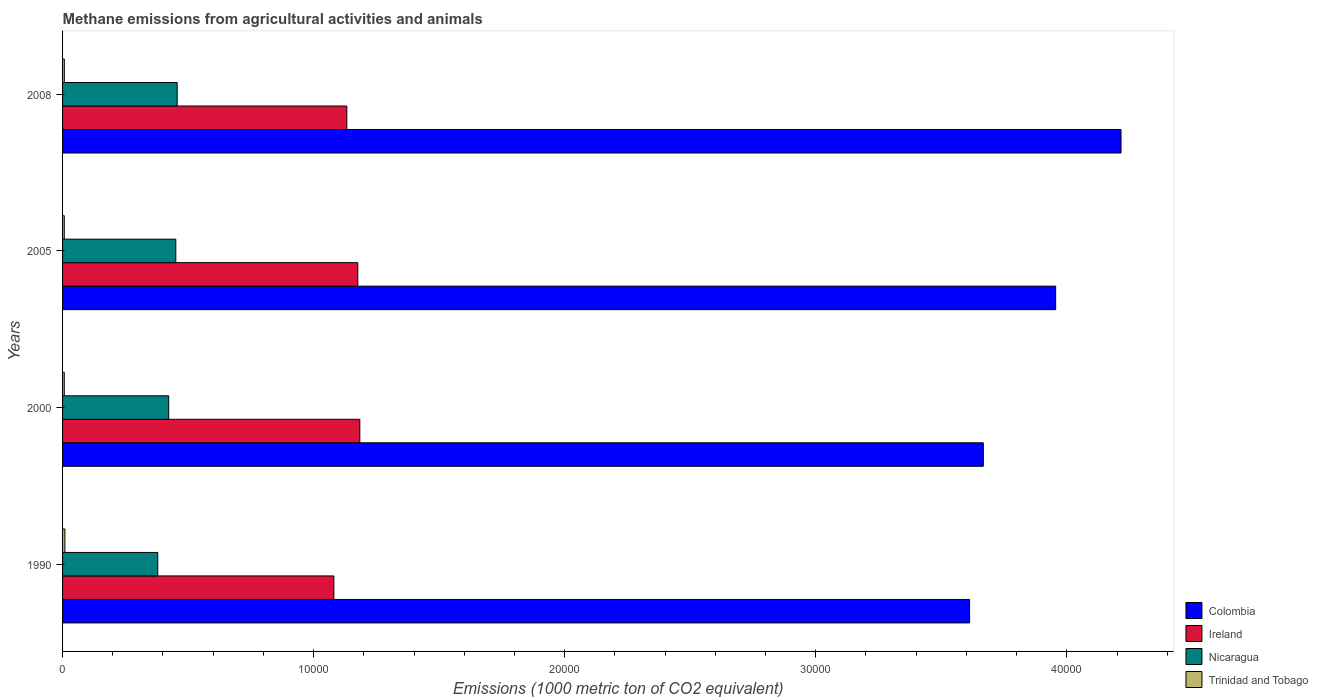How many different coloured bars are there?
Ensure brevity in your answer.  4. How many groups of bars are there?
Give a very brief answer. 4. What is the label of the 1st group of bars from the top?
Provide a short and direct response. 2008. What is the amount of methane emitted in Ireland in 1990?
Offer a terse response. 1.08e+04. Across all years, what is the maximum amount of methane emitted in Ireland?
Provide a short and direct response. 1.18e+04. Across all years, what is the minimum amount of methane emitted in Ireland?
Provide a succinct answer. 1.08e+04. What is the total amount of methane emitted in Trinidad and Tobago in the graph?
Give a very brief answer. 299.8. What is the difference between the amount of methane emitted in Trinidad and Tobago in 2005 and that in 2008?
Give a very brief answer. -2.9. What is the difference between the amount of methane emitted in Trinidad and Tobago in 2005 and the amount of methane emitted in Ireland in 2008?
Your response must be concise. -1.13e+04. What is the average amount of methane emitted in Nicaragua per year?
Your response must be concise. 4273.6. In the year 2000, what is the difference between the amount of methane emitted in Trinidad and Tobago and amount of methane emitted in Colombia?
Offer a very short reply. -3.66e+04. What is the ratio of the amount of methane emitted in Colombia in 2000 to that in 2008?
Offer a terse response. 0.87. Is the difference between the amount of methane emitted in Trinidad and Tobago in 1990 and 2000 greater than the difference between the amount of methane emitted in Colombia in 1990 and 2000?
Provide a succinct answer. Yes. What is the difference between the highest and the second highest amount of methane emitted in Ireland?
Provide a succinct answer. 81.2. What is the difference between the highest and the lowest amount of methane emitted in Trinidad and Tobago?
Ensure brevity in your answer.  24.7. In how many years, is the amount of methane emitted in Ireland greater than the average amount of methane emitted in Ireland taken over all years?
Make the answer very short. 2. Is it the case that in every year, the sum of the amount of methane emitted in Colombia and amount of methane emitted in Nicaragua is greater than the sum of amount of methane emitted in Ireland and amount of methane emitted in Trinidad and Tobago?
Offer a terse response. No. What does the 1st bar from the top in 2008 represents?
Make the answer very short. Trinidad and Tobago. What does the 2nd bar from the bottom in 2000 represents?
Your answer should be compact. Ireland. How many bars are there?
Keep it short and to the point. 16. Are all the bars in the graph horizontal?
Make the answer very short. Yes. How many years are there in the graph?
Your answer should be very brief. 4. Does the graph contain any zero values?
Your response must be concise. No. Does the graph contain grids?
Provide a succinct answer. No. Where does the legend appear in the graph?
Ensure brevity in your answer.  Bottom right. How are the legend labels stacked?
Make the answer very short. Vertical. What is the title of the graph?
Offer a terse response. Methane emissions from agricultural activities and animals. What is the label or title of the X-axis?
Ensure brevity in your answer.  Emissions (1000 metric ton of CO2 equivalent). What is the Emissions (1000 metric ton of CO2 equivalent) in Colombia in 1990?
Provide a succinct answer. 3.61e+04. What is the Emissions (1000 metric ton of CO2 equivalent) of Ireland in 1990?
Provide a short and direct response. 1.08e+04. What is the Emissions (1000 metric ton of CO2 equivalent) of Nicaragua in 1990?
Your response must be concise. 3791.8. What is the Emissions (1000 metric ton of CO2 equivalent) of Trinidad and Tobago in 1990?
Ensure brevity in your answer.  92.7. What is the Emissions (1000 metric ton of CO2 equivalent) of Colombia in 2000?
Offer a terse response. 3.67e+04. What is the Emissions (1000 metric ton of CO2 equivalent) in Ireland in 2000?
Give a very brief answer. 1.18e+04. What is the Emissions (1000 metric ton of CO2 equivalent) in Nicaragua in 2000?
Give a very brief answer. 4227.1. What is the Emissions (1000 metric ton of CO2 equivalent) in Colombia in 2005?
Make the answer very short. 3.96e+04. What is the Emissions (1000 metric ton of CO2 equivalent) in Ireland in 2005?
Offer a very short reply. 1.18e+04. What is the Emissions (1000 metric ton of CO2 equivalent) of Nicaragua in 2005?
Provide a succinct answer. 4510. What is the Emissions (1000 metric ton of CO2 equivalent) of Trinidad and Tobago in 2005?
Provide a succinct answer. 68.1. What is the Emissions (1000 metric ton of CO2 equivalent) in Colombia in 2008?
Offer a very short reply. 4.22e+04. What is the Emissions (1000 metric ton of CO2 equivalent) in Ireland in 2008?
Ensure brevity in your answer.  1.13e+04. What is the Emissions (1000 metric ton of CO2 equivalent) in Nicaragua in 2008?
Your answer should be very brief. 4565.5. What is the Emissions (1000 metric ton of CO2 equivalent) in Trinidad and Tobago in 2008?
Make the answer very short. 71. Across all years, what is the maximum Emissions (1000 metric ton of CO2 equivalent) in Colombia?
Give a very brief answer. 4.22e+04. Across all years, what is the maximum Emissions (1000 metric ton of CO2 equivalent) of Ireland?
Ensure brevity in your answer.  1.18e+04. Across all years, what is the maximum Emissions (1000 metric ton of CO2 equivalent) in Nicaragua?
Your response must be concise. 4565.5. Across all years, what is the maximum Emissions (1000 metric ton of CO2 equivalent) of Trinidad and Tobago?
Offer a terse response. 92.7. Across all years, what is the minimum Emissions (1000 metric ton of CO2 equivalent) of Colombia?
Offer a very short reply. 3.61e+04. Across all years, what is the minimum Emissions (1000 metric ton of CO2 equivalent) of Ireland?
Ensure brevity in your answer.  1.08e+04. Across all years, what is the minimum Emissions (1000 metric ton of CO2 equivalent) in Nicaragua?
Your response must be concise. 3791.8. What is the total Emissions (1000 metric ton of CO2 equivalent) of Colombia in the graph?
Your answer should be very brief. 1.55e+05. What is the total Emissions (1000 metric ton of CO2 equivalent) of Ireland in the graph?
Keep it short and to the point. 4.57e+04. What is the total Emissions (1000 metric ton of CO2 equivalent) of Nicaragua in the graph?
Provide a short and direct response. 1.71e+04. What is the total Emissions (1000 metric ton of CO2 equivalent) in Trinidad and Tobago in the graph?
Your answer should be very brief. 299.8. What is the difference between the Emissions (1000 metric ton of CO2 equivalent) of Colombia in 1990 and that in 2000?
Your response must be concise. -546.7. What is the difference between the Emissions (1000 metric ton of CO2 equivalent) in Ireland in 1990 and that in 2000?
Provide a succinct answer. -1033.1. What is the difference between the Emissions (1000 metric ton of CO2 equivalent) of Nicaragua in 1990 and that in 2000?
Ensure brevity in your answer.  -435.3. What is the difference between the Emissions (1000 metric ton of CO2 equivalent) in Trinidad and Tobago in 1990 and that in 2000?
Offer a very short reply. 24.7. What is the difference between the Emissions (1000 metric ton of CO2 equivalent) of Colombia in 1990 and that in 2005?
Your response must be concise. -3428.3. What is the difference between the Emissions (1000 metric ton of CO2 equivalent) in Ireland in 1990 and that in 2005?
Offer a terse response. -951.9. What is the difference between the Emissions (1000 metric ton of CO2 equivalent) in Nicaragua in 1990 and that in 2005?
Offer a very short reply. -718.2. What is the difference between the Emissions (1000 metric ton of CO2 equivalent) in Trinidad and Tobago in 1990 and that in 2005?
Provide a succinct answer. 24.6. What is the difference between the Emissions (1000 metric ton of CO2 equivalent) of Colombia in 1990 and that in 2008?
Your answer should be compact. -6031.9. What is the difference between the Emissions (1000 metric ton of CO2 equivalent) of Ireland in 1990 and that in 2008?
Keep it short and to the point. -516. What is the difference between the Emissions (1000 metric ton of CO2 equivalent) of Nicaragua in 1990 and that in 2008?
Ensure brevity in your answer.  -773.7. What is the difference between the Emissions (1000 metric ton of CO2 equivalent) in Trinidad and Tobago in 1990 and that in 2008?
Your answer should be compact. 21.7. What is the difference between the Emissions (1000 metric ton of CO2 equivalent) of Colombia in 2000 and that in 2005?
Make the answer very short. -2881.6. What is the difference between the Emissions (1000 metric ton of CO2 equivalent) of Ireland in 2000 and that in 2005?
Keep it short and to the point. 81.2. What is the difference between the Emissions (1000 metric ton of CO2 equivalent) of Nicaragua in 2000 and that in 2005?
Offer a terse response. -282.9. What is the difference between the Emissions (1000 metric ton of CO2 equivalent) of Trinidad and Tobago in 2000 and that in 2005?
Offer a very short reply. -0.1. What is the difference between the Emissions (1000 metric ton of CO2 equivalent) of Colombia in 2000 and that in 2008?
Give a very brief answer. -5485.2. What is the difference between the Emissions (1000 metric ton of CO2 equivalent) of Ireland in 2000 and that in 2008?
Your answer should be very brief. 517.1. What is the difference between the Emissions (1000 metric ton of CO2 equivalent) of Nicaragua in 2000 and that in 2008?
Provide a short and direct response. -338.4. What is the difference between the Emissions (1000 metric ton of CO2 equivalent) in Colombia in 2005 and that in 2008?
Your answer should be compact. -2603.6. What is the difference between the Emissions (1000 metric ton of CO2 equivalent) of Ireland in 2005 and that in 2008?
Offer a very short reply. 435.9. What is the difference between the Emissions (1000 metric ton of CO2 equivalent) of Nicaragua in 2005 and that in 2008?
Your answer should be very brief. -55.5. What is the difference between the Emissions (1000 metric ton of CO2 equivalent) in Colombia in 1990 and the Emissions (1000 metric ton of CO2 equivalent) in Ireland in 2000?
Offer a terse response. 2.43e+04. What is the difference between the Emissions (1000 metric ton of CO2 equivalent) of Colombia in 1990 and the Emissions (1000 metric ton of CO2 equivalent) of Nicaragua in 2000?
Provide a short and direct response. 3.19e+04. What is the difference between the Emissions (1000 metric ton of CO2 equivalent) of Colombia in 1990 and the Emissions (1000 metric ton of CO2 equivalent) of Trinidad and Tobago in 2000?
Ensure brevity in your answer.  3.61e+04. What is the difference between the Emissions (1000 metric ton of CO2 equivalent) in Ireland in 1990 and the Emissions (1000 metric ton of CO2 equivalent) in Nicaragua in 2000?
Keep it short and to the point. 6579.4. What is the difference between the Emissions (1000 metric ton of CO2 equivalent) of Ireland in 1990 and the Emissions (1000 metric ton of CO2 equivalent) of Trinidad and Tobago in 2000?
Ensure brevity in your answer.  1.07e+04. What is the difference between the Emissions (1000 metric ton of CO2 equivalent) of Nicaragua in 1990 and the Emissions (1000 metric ton of CO2 equivalent) of Trinidad and Tobago in 2000?
Offer a very short reply. 3723.8. What is the difference between the Emissions (1000 metric ton of CO2 equivalent) in Colombia in 1990 and the Emissions (1000 metric ton of CO2 equivalent) in Ireland in 2005?
Provide a short and direct response. 2.44e+04. What is the difference between the Emissions (1000 metric ton of CO2 equivalent) in Colombia in 1990 and the Emissions (1000 metric ton of CO2 equivalent) in Nicaragua in 2005?
Provide a short and direct response. 3.16e+04. What is the difference between the Emissions (1000 metric ton of CO2 equivalent) of Colombia in 1990 and the Emissions (1000 metric ton of CO2 equivalent) of Trinidad and Tobago in 2005?
Your answer should be compact. 3.61e+04. What is the difference between the Emissions (1000 metric ton of CO2 equivalent) of Ireland in 1990 and the Emissions (1000 metric ton of CO2 equivalent) of Nicaragua in 2005?
Keep it short and to the point. 6296.5. What is the difference between the Emissions (1000 metric ton of CO2 equivalent) of Ireland in 1990 and the Emissions (1000 metric ton of CO2 equivalent) of Trinidad and Tobago in 2005?
Provide a succinct answer. 1.07e+04. What is the difference between the Emissions (1000 metric ton of CO2 equivalent) in Nicaragua in 1990 and the Emissions (1000 metric ton of CO2 equivalent) in Trinidad and Tobago in 2005?
Provide a succinct answer. 3723.7. What is the difference between the Emissions (1000 metric ton of CO2 equivalent) in Colombia in 1990 and the Emissions (1000 metric ton of CO2 equivalent) in Ireland in 2008?
Offer a very short reply. 2.48e+04. What is the difference between the Emissions (1000 metric ton of CO2 equivalent) in Colombia in 1990 and the Emissions (1000 metric ton of CO2 equivalent) in Nicaragua in 2008?
Your response must be concise. 3.16e+04. What is the difference between the Emissions (1000 metric ton of CO2 equivalent) in Colombia in 1990 and the Emissions (1000 metric ton of CO2 equivalent) in Trinidad and Tobago in 2008?
Keep it short and to the point. 3.61e+04. What is the difference between the Emissions (1000 metric ton of CO2 equivalent) of Ireland in 1990 and the Emissions (1000 metric ton of CO2 equivalent) of Nicaragua in 2008?
Ensure brevity in your answer.  6241. What is the difference between the Emissions (1000 metric ton of CO2 equivalent) in Ireland in 1990 and the Emissions (1000 metric ton of CO2 equivalent) in Trinidad and Tobago in 2008?
Make the answer very short. 1.07e+04. What is the difference between the Emissions (1000 metric ton of CO2 equivalent) in Nicaragua in 1990 and the Emissions (1000 metric ton of CO2 equivalent) in Trinidad and Tobago in 2008?
Your response must be concise. 3720.8. What is the difference between the Emissions (1000 metric ton of CO2 equivalent) in Colombia in 2000 and the Emissions (1000 metric ton of CO2 equivalent) in Ireland in 2005?
Ensure brevity in your answer.  2.49e+04. What is the difference between the Emissions (1000 metric ton of CO2 equivalent) in Colombia in 2000 and the Emissions (1000 metric ton of CO2 equivalent) in Nicaragua in 2005?
Give a very brief answer. 3.22e+04. What is the difference between the Emissions (1000 metric ton of CO2 equivalent) in Colombia in 2000 and the Emissions (1000 metric ton of CO2 equivalent) in Trinidad and Tobago in 2005?
Ensure brevity in your answer.  3.66e+04. What is the difference between the Emissions (1000 metric ton of CO2 equivalent) in Ireland in 2000 and the Emissions (1000 metric ton of CO2 equivalent) in Nicaragua in 2005?
Offer a terse response. 7329.6. What is the difference between the Emissions (1000 metric ton of CO2 equivalent) of Ireland in 2000 and the Emissions (1000 metric ton of CO2 equivalent) of Trinidad and Tobago in 2005?
Your answer should be compact. 1.18e+04. What is the difference between the Emissions (1000 metric ton of CO2 equivalent) in Nicaragua in 2000 and the Emissions (1000 metric ton of CO2 equivalent) in Trinidad and Tobago in 2005?
Offer a very short reply. 4159. What is the difference between the Emissions (1000 metric ton of CO2 equivalent) of Colombia in 2000 and the Emissions (1000 metric ton of CO2 equivalent) of Ireland in 2008?
Offer a very short reply. 2.54e+04. What is the difference between the Emissions (1000 metric ton of CO2 equivalent) of Colombia in 2000 and the Emissions (1000 metric ton of CO2 equivalent) of Nicaragua in 2008?
Ensure brevity in your answer.  3.21e+04. What is the difference between the Emissions (1000 metric ton of CO2 equivalent) of Colombia in 2000 and the Emissions (1000 metric ton of CO2 equivalent) of Trinidad and Tobago in 2008?
Ensure brevity in your answer.  3.66e+04. What is the difference between the Emissions (1000 metric ton of CO2 equivalent) of Ireland in 2000 and the Emissions (1000 metric ton of CO2 equivalent) of Nicaragua in 2008?
Provide a short and direct response. 7274.1. What is the difference between the Emissions (1000 metric ton of CO2 equivalent) in Ireland in 2000 and the Emissions (1000 metric ton of CO2 equivalent) in Trinidad and Tobago in 2008?
Ensure brevity in your answer.  1.18e+04. What is the difference between the Emissions (1000 metric ton of CO2 equivalent) of Nicaragua in 2000 and the Emissions (1000 metric ton of CO2 equivalent) of Trinidad and Tobago in 2008?
Give a very brief answer. 4156.1. What is the difference between the Emissions (1000 metric ton of CO2 equivalent) in Colombia in 2005 and the Emissions (1000 metric ton of CO2 equivalent) in Ireland in 2008?
Your response must be concise. 2.82e+04. What is the difference between the Emissions (1000 metric ton of CO2 equivalent) in Colombia in 2005 and the Emissions (1000 metric ton of CO2 equivalent) in Nicaragua in 2008?
Offer a very short reply. 3.50e+04. What is the difference between the Emissions (1000 metric ton of CO2 equivalent) in Colombia in 2005 and the Emissions (1000 metric ton of CO2 equivalent) in Trinidad and Tobago in 2008?
Your answer should be very brief. 3.95e+04. What is the difference between the Emissions (1000 metric ton of CO2 equivalent) of Ireland in 2005 and the Emissions (1000 metric ton of CO2 equivalent) of Nicaragua in 2008?
Offer a terse response. 7192.9. What is the difference between the Emissions (1000 metric ton of CO2 equivalent) in Ireland in 2005 and the Emissions (1000 metric ton of CO2 equivalent) in Trinidad and Tobago in 2008?
Provide a short and direct response. 1.17e+04. What is the difference between the Emissions (1000 metric ton of CO2 equivalent) in Nicaragua in 2005 and the Emissions (1000 metric ton of CO2 equivalent) in Trinidad and Tobago in 2008?
Ensure brevity in your answer.  4439. What is the average Emissions (1000 metric ton of CO2 equivalent) in Colombia per year?
Keep it short and to the point. 3.86e+04. What is the average Emissions (1000 metric ton of CO2 equivalent) of Ireland per year?
Provide a short and direct response. 1.14e+04. What is the average Emissions (1000 metric ton of CO2 equivalent) in Nicaragua per year?
Offer a terse response. 4273.6. What is the average Emissions (1000 metric ton of CO2 equivalent) of Trinidad and Tobago per year?
Provide a short and direct response. 74.95. In the year 1990, what is the difference between the Emissions (1000 metric ton of CO2 equivalent) in Colombia and Emissions (1000 metric ton of CO2 equivalent) in Ireland?
Your answer should be very brief. 2.53e+04. In the year 1990, what is the difference between the Emissions (1000 metric ton of CO2 equivalent) in Colombia and Emissions (1000 metric ton of CO2 equivalent) in Nicaragua?
Your answer should be compact. 3.23e+04. In the year 1990, what is the difference between the Emissions (1000 metric ton of CO2 equivalent) in Colombia and Emissions (1000 metric ton of CO2 equivalent) in Trinidad and Tobago?
Your response must be concise. 3.60e+04. In the year 1990, what is the difference between the Emissions (1000 metric ton of CO2 equivalent) in Ireland and Emissions (1000 metric ton of CO2 equivalent) in Nicaragua?
Your response must be concise. 7014.7. In the year 1990, what is the difference between the Emissions (1000 metric ton of CO2 equivalent) of Ireland and Emissions (1000 metric ton of CO2 equivalent) of Trinidad and Tobago?
Your response must be concise. 1.07e+04. In the year 1990, what is the difference between the Emissions (1000 metric ton of CO2 equivalent) of Nicaragua and Emissions (1000 metric ton of CO2 equivalent) of Trinidad and Tobago?
Make the answer very short. 3699.1. In the year 2000, what is the difference between the Emissions (1000 metric ton of CO2 equivalent) in Colombia and Emissions (1000 metric ton of CO2 equivalent) in Ireland?
Your answer should be very brief. 2.48e+04. In the year 2000, what is the difference between the Emissions (1000 metric ton of CO2 equivalent) in Colombia and Emissions (1000 metric ton of CO2 equivalent) in Nicaragua?
Give a very brief answer. 3.24e+04. In the year 2000, what is the difference between the Emissions (1000 metric ton of CO2 equivalent) of Colombia and Emissions (1000 metric ton of CO2 equivalent) of Trinidad and Tobago?
Your response must be concise. 3.66e+04. In the year 2000, what is the difference between the Emissions (1000 metric ton of CO2 equivalent) of Ireland and Emissions (1000 metric ton of CO2 equivalent) of Nicaragua?
Provide a succinct answer. 7612.5. In the year 2000, what is the difference between the Emissions (1000 metric ton of CO2 equivalent) of Ireland and Emissions (1000 metric ton of CO2 equivalent) of Trinidad and Tobago?
Your answer should be compact. 1.18e+04. In the year 2000, what is the difference between the Emissions (1000 metric ton of CO2 equivalent) in Nicaragua and Emissions (1000 metric ton of CO2 equivalent) in Trinidad and Tobago?
Your response must be concise. 4159.1. In the year 2005, what is the difference between the Emissions (1000 metric ton of CO2 equivalent) in Colombia and Emissions (1000 metric ton of CO2 equivalent) in Ireland?
Offer a very short reply. 2.78e+04. In the year 2005, what is the difference between the Emissions (1000 metric ton of CO2 equivalent) of Colombia and Emissions (1000 metric ton of CO2 equivalent) of Nicaragua?
Provide a short and direct response. 3.50e+04. In the year 2005, what is the difference between the Emissions (1000 metric ton of CO2 equivalent) of Colombia and Emissions (1000 metric ton of CO2 equivalent) of Trinidad and Tobago?
Keep it short and to the point. 3.95e+04. In the year 2005, what is the difference between the Emissions (1000 metric ton of CO2 equivalent) in Ireland and Emissions (1000 metric ton of CO2 equivalent) in Nicaragua?
Your answer should be very brief. 7248.4. In the year 2005, what is the difference between the Emissions (1000 metric ton of CO2 equivalent) in Ireland and Emissions (1000 metric ton of CO2 equivalent) in Trinidad and Tobago?
Ensure brevity in your answer.  1.17e+04. In the year 2005, what is the difference between the Emissions (1000 metric ton of CO2 equivalent) in Nicaragua and Emissions (1000 metric ton of CO2 equivalent) in Trinidad and Tobago?
Keep it short and to the point. 4441.9. In the year 2008, what is the difference between the Emissions (1000 metric ton of CO2 equivalent) in Colombia and Emissions (1000 metric ton of CO2 equivalent) in Ireland?
Offer a very short reply. 3.08e+04. In the year 2008, what is the difference between the Emissions (1000 metric ton of CO2 equivalent) of Colombia and Emissions (1000 metric ton of CO2 equivalent) of Nicaragua?
Provide a succinct answer. 3.76e+04. In the year 2008, what is the difference between the Emissions (1000 metric ton of CO2 equivalent) in Colombia and Emissions (1000 metric ton of CO2 equivalent) in Trinidad and Tobago?
Your answer should be compact. 4.21e+04. In the year 2008, what is the difference between the Emissions (1000 metric ton of CO2 equivalent) of Ireland and Emissions (1000 metric ton of CO2 equivalent) of Nicaragua?
Give a very brief answer. 6757. In the year 2008, what is the difference between the Emissions (1000 metric ton of CO2 equivalent) of Ireland and Emissions (1000 metric ton of CO2 equivalent) of Trinidad and Tobago?
Make the answer very short. 1.13e+04. In the year 2008, what is the difference between the Emissions (1000 metric ton of CO2 equivalent) in Nicaragua and Emissions (1000 metric ton of CO2 equivalent) in Trinidad and Tobago?
Provide a short and direct response. 4494.5. What is the ratio of the Emissions (1000 metric ton of CO2 equivalent) in Colombia in 1990 to that in 2000?
Provide a short and direct response. 0.99. What is the ratio of the Emissions (1000 metric ton of CO2 equivalent) of Ireland in 1990 to that in 2000?
Your answer should be compact. 0.91. What is the ratio of the Emissions (1000 metric ton of CO2 equivalent) in Nicaragua in 1990 to that in 2000?
Provide a short and direct response. 0.9. What is the ratio of the Emissions (1000 metric ton of CO2 equivalent) in Trinidad and Tobago in 1990 to that in 2000?
Your answer should be very brief. 1.36. What is the ratio of the Emissions (1000 metric ton of CO2 equivalent) in Colombia in 1990 to that in 2005?
Your answer should be compact. 0.91. What is the ratio of the Emissions (1000 metric ton of CO2 equivalent) of Ireland in 1990 to that in 2005?
Keep it short and to the point. 0.92. What is the ratio of the Emissions (1000 metric ton of CO2 equivalent) of Nicaragua in 1990 to that in 2005?
Provide a succinct answer. 0.84. What is the ratio of the Emissions (1000 metric ton of CO2 equivalent) in Trinidad and Tobago in 1990 to that in 2005?
Your response must be concise. 1.36. What is the ratio of the Emissions (1000 metric ton of CO2 equivalent) of Colombia in 1990 to that in 2008?
Give a very brief answer. 0.86. What is the ratio of the Emissions (1000 metric ton of CO2 equivalent) in Ireland in 1990 to that in 2008?
Provide a succinct answer. 0.95. What is the ratio of the Emissions (1000 metric ton of CO2 equivalent) of Nicaragua in 1990 to that in 2008?
Give a very brief answer. 0.83. What is the ratio of the Emissions (1000 metric ton of CO2 equivalent) of Trinidad and Tobago in 1990 to that in 2008?
Make the answer very short. 1.31. What is the ratio of the Emissions (1000 metric ton of CO2 equivalent) in Colombia in 2000 to that in 2005?
Ensure brevity in your answer.  0.93. What is the ratio of the Emissions (1000 metric ton of CO2 equivalent) of Nicaragua in 2000 to that in 2005?
Your answer should be compact. 0.94. What is the ratio of the Emissions (1000 metric ton of CO2 equivalent) of Colombia in 2000 to that in 2008?
Provide a short and direct response. 0.87. What is the ratio of the Emissions (1000 metric ton of CO2 equivalent) in Ireland in 2000 to that in 2008?
Make the answer very short. 1.05. What is the ratio of the Emissions (1000 metric ton of CO2 equivalent) of Nicaragua in 2000 to that in 2008?
Make the answer very short. 0.93. What is the ratio of the Emissions (1000 metric ton of CO2 equivalent) in Trinidad and Tobago in 2000 to that in 2008?
Your answer should be compact. 0.96. What is the ratio of the Emissions (1000 metric ton of CO2 equivalent) in Colombia in 2005 to that in 2008?
Offer a very short reply. 0.94. What is the ratio of the Emissions (1000 metric ton of CO2 equivalent) of Ireland in 2005 to that in 2008?
Give a very brief answer. 1.04. What is the ratio of the Emissions (1000 metric ton of CO2 equivalent) in Trinidad and Tobago in 2005 to that in 2008?
Ensure brevity in your answer.  0.96. What is the difference between the highest and the second highest Emissions (1000 metric ton of CO2 equivalent) of Colombia?
Keep it short and to the point. 2603.6. What is the difference between the highest and the second highest Emissions (1000 metric ton of CO2 equivalent) of Ireland?
Your response must be concise. 81.2. What is the difference between the highest and the second highest Emissions (1000 metric ton of CO2 equivalent) of Nicaragua?
Keep it short and to the point. 55.5. What is the difference between the highest and the second highest Emissions (1000 metric ton of CO2 equivalent) of Trinidad and Tobago?
Ensure brevity in your answer.  21.7. What is the difference between the highest and the lowest Emissions (1000 metric ton of CO2 equivalent) in Colombia?
Provide a short and direct response. 6031.9. What is the difference between the highest and the lowest Emissions (1000 metric ton of CO2 equivalent) of Ireland?
Make the answer very short. 1033.1. What is the difference between the highest and the lowest Emissions (1000 metric ton of CO2 equivalent) of Nicaragua?
Offer a very short reply. 773.7. What is the difference between the highest and the lowest Emissions (1000 metric ton of CO2 equivalent) in Trinidad and Tobago?
Offer a very short reply. 24.7. 